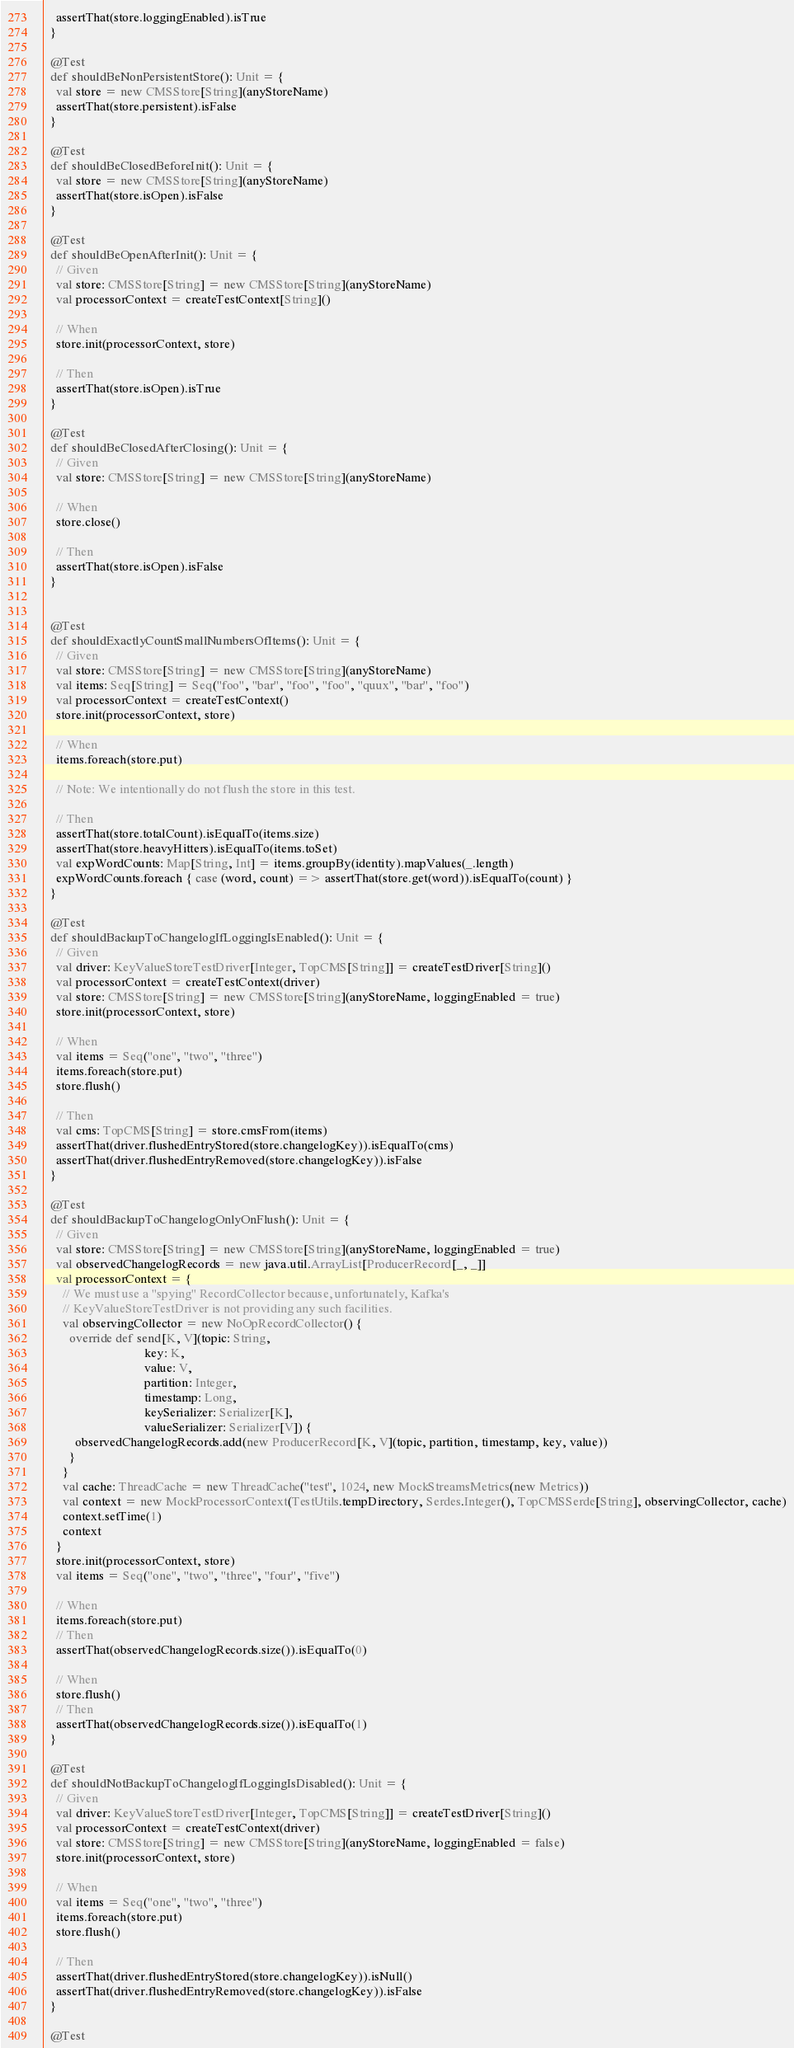<code> <loc_0><loc_0><loc_500><loc_500><_Scala_>    assertThat(store.loggingEnabled).isTrue
  }

  @Test
  def shouldBeNonPersistentStore(): Unit = {
    val store = new CMSStore[String](anyStoreName)
    assertThat(store.persistent).isFalse
  }

  @Test
  def shouldBeClosedBeforeInit(): Unit = {
    val store = new CMSStore[String](anyStoreName)
    assertThat(store.isOpen).isFalse
  }

  @Test
  def shouldBeOpenAfterInit(): Unit = {
    // Given
    val store: CMSStore[String] = new CMSStore[String](anyStoreName)
    val processorContext = createTestContext[String]()

    // When
    store.init(processorContext, store)

    // Then
    assertThat(store.isOpen).isTrue
  }

  @Test
  def shouldBeClosedAfterClosing(): Unit = {
    // Given
    val store: CMSStore[String] = new CMSStore[String](anyStoreName)

    // When
    store.close()

    // Then
    assertThat(store.isOpen).isFalse
  }


  @Test
  def shouldExactlyCountSmallNumbersOfItems(): Unit = {
    // Given
    val store: CMSStore[String] = new CMSStore[String](anyStoreName)
    val items: Seq[String] = Seq("foo", "bar", "foo", "foo", "quux", "bar", "foo")
    val processorContext = createTestContext()
    store.init(processorContext, store)

    // When
    items.foreach(store.put)

    // Note: We intentionally do not flush the store in this test.

    // Then
    assertThat(store.totalCount).isEqualTo(items.size)
    assertThat(store.heavyHitters).isEqualTo(items.toSet)
    val expWordCounts: Map[String, Int] = items.groupBy(identity).mapValues(_.length)
    expWordCounts.foreach { case (word, count) => assertThat(store.get(word)).isEqualTo(count) }
  }

  @Test
  def shouldBackupToChangelogIfLoggingIsEnabled(): Unit = {
    // Given
    val driver: KeyValueStoreTestDriver[Integer, TopCMS[String]] = createTestDriver[String]()
    val processorContext = createTestContext(driver)
    val store: CMSStore[String] = new CMSStore[String](anyStoreName, loggingEnabled = true)
    store.init(processorContext, store)

    // When
    val items = Seq("one", "two", "three")
    items.foreach(store.put)
    store.flush()

    // Then
    val cms: TopCMS[String] = store.cmsFrom(items)
    assertThat(driver.flushedEntryStored(store.changelogKey)).isEqualTo(cms)
    assertThat(driver.flushedEntryRemoved(store.changelogKey)).isFalse
  }

  @Test
  def shouldBackupToChangelogOnlyOnFlush(): Unit = {
    // Given
    val store: CMSStore[String] = new CMSStore[String](anyStoreName, loggingEnabled = true)
    val observedChangelogRecords = new java.util.ArrayList[ProducerRecord[_, _]]
    val processorContext = {
      // We must use a "spying" RecordCollector because, unfortunately, Kafka's
      // KeyValueStoreTestDriver is not providing any such facilities.
      val observingCollector = new NoOpRecordCollector() {
        override def send[K, V](topic: String,
                                key: K,
                                value: V,
                                partition: Integer,
                                timestamp: Long,
                                keySerializer: Serializer[K],
                                valueSerializer: Serializer[V]) {
          observedChangelogRecords.add(new ProducerRecord[K, V](topic, partition, timestamp, key, value))
        }
      }
      val cache: ThreadCache = new ThreadCache("test", 1024, new MockStreamsMetrics(new Metrics))
      val context = new MockProcessorContext(TestUtils.tempDirectory, Serdes.Integer(), TopCMSSerde[String], observingCollector, cache)
      context.setTime(1)
      context
    }
    store.init(processorContext, store)
    val items = Seq("one", "two", "three", "four", "five")

    // When
    items.foreach(store.put)
    // Then
    assertThat(observedChangelogRecords.size()).isEqualTo(0)

    // When
    store.flush()
    // Then
    assertThat(observedChangelogRecords.size()).isEqualTo(1)
  }

  @Test
  def shouldNotBackupToChangelogIfLoggingIsDisabled(): Unit = {
    // Given
    val driver: KeyValueStoreTestDriver[Integer, TopCMS[String]] = createTestDriver[String]()
    val processorContext = createTestContext(driver)
    val store: CMSStore[String] = new CMSStore[String](anyStoreName, loggingEnabled = false)
    store.init(processorContext, store)

    // When
    val items = Seq("one", "two", "three")
    items.foreach(store.put)
    store.flush()

    // Then
    assertThat(driver.flushedEntryStored(store.changelogKey)).isNull()
    assertThat(driver.flushedEntryRemoved(store.changelogKey)).isFalse
  }

  @Test</code> 